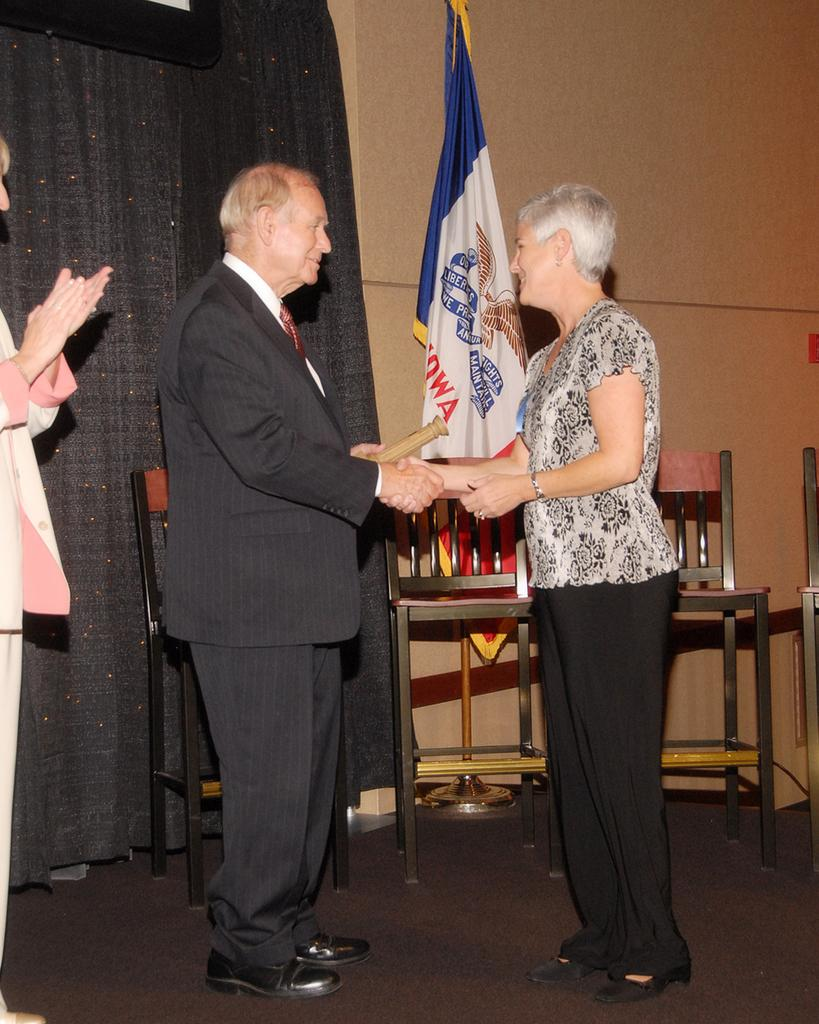How many people are present in the room? There are 3 people in the room. What are the people at the right side of the room doing? The people at the right are greeting each other. What can be seen behind the people? There are chairs and a flag behind the people. What type of window treatment is present at the left side of the room? There is a black curtain at the left side of the room. What caption is written on the flag behind the people? There is no caption visible on the flag in the image. How far is the range of the side table from the people? There is no side table present in the image. 